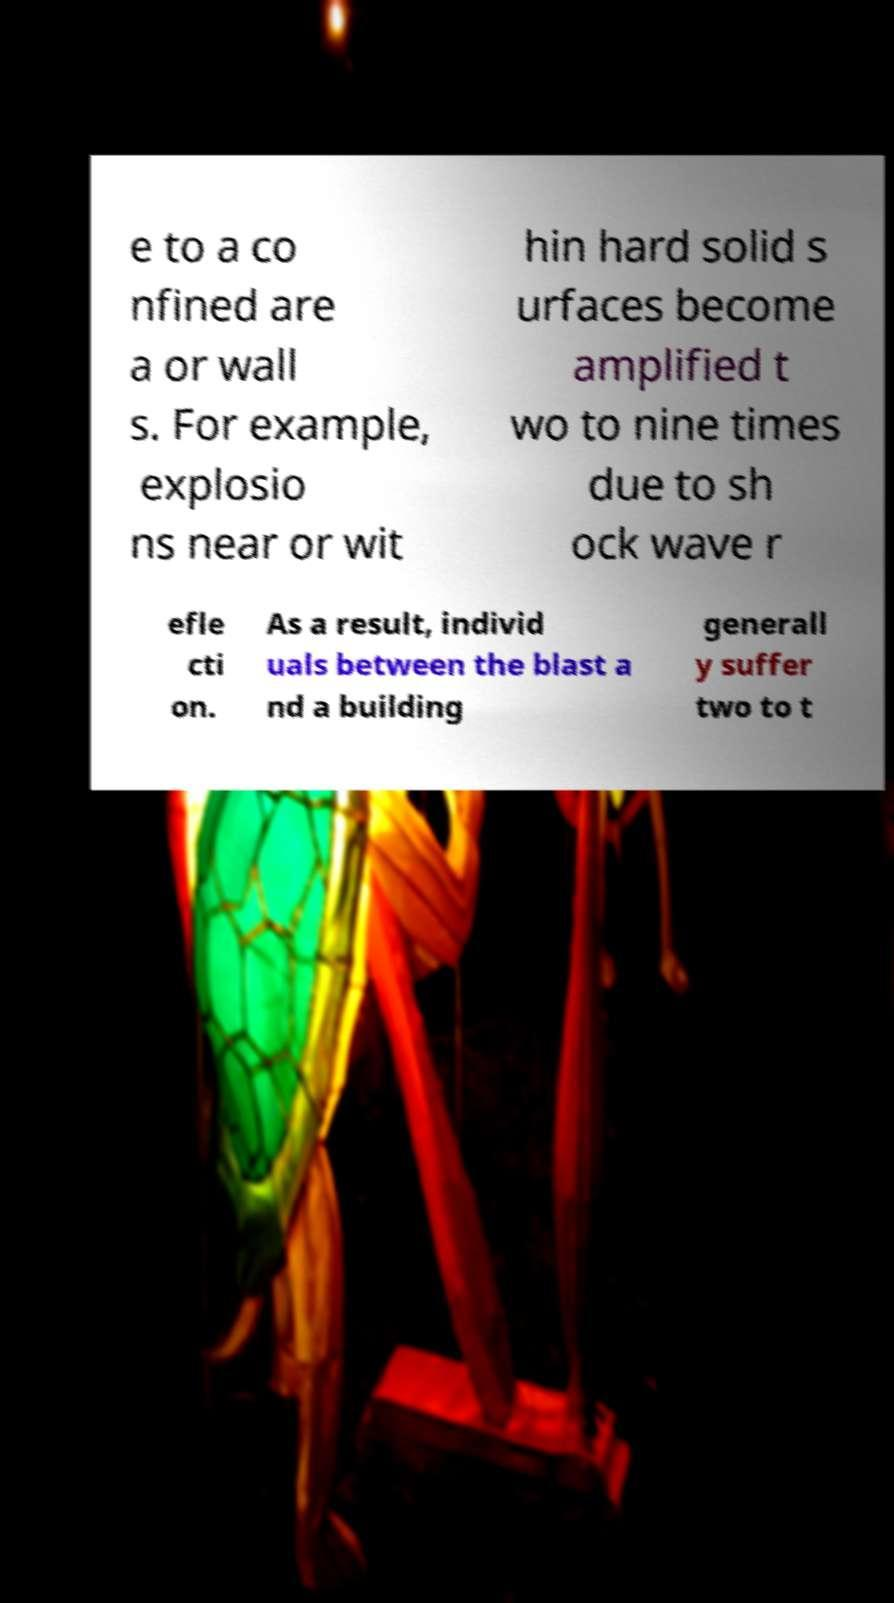Could you assist in decoding the text presented in this image and type it out clearly? e to a co nfined are a or wall s. For example, explosio ns near or wit hin hard solid s urfaces become amplified t wo to nine times due to sh ock wave r efle cti on. As a result, individ uals between the blast a nd a building generall y suffer two to t 